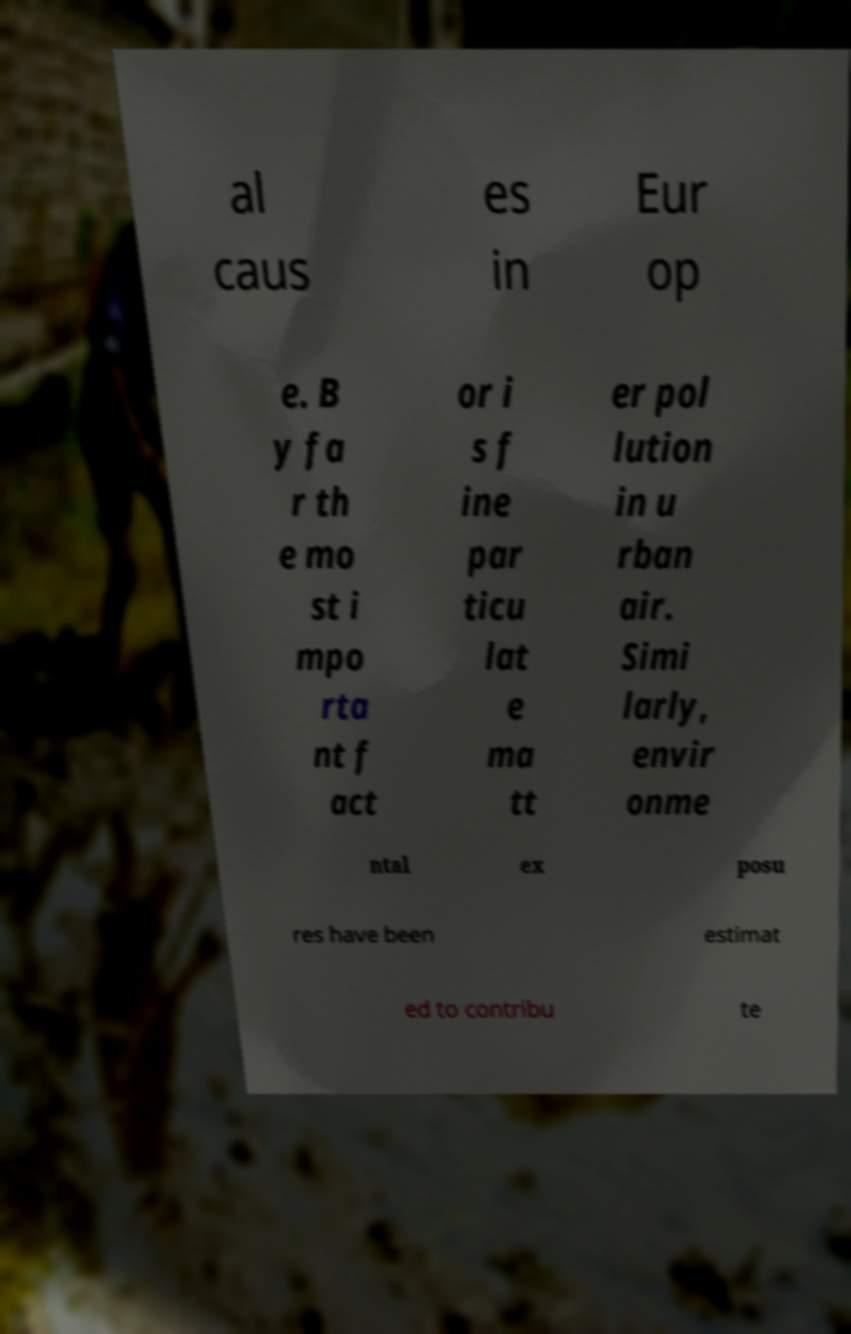I need the written content from this picture converted into text. Can you do that? al caus es in Eur op e. B y fa r th e mo st i mpo rta nt f act or i s f ine par ticu lat e ma tt er pol lution in u rban air. Simi larly, envir onme ntal ex posu res have been estimat ed to contribu te 